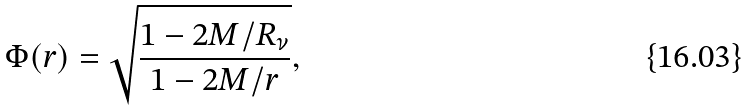Convert formula to latex. <formula><loc_0><loc_0><loc_500><loc_500>\Phi ( r ) = \sqrt { \frac { 1 - 2 M / R _ { \nu } } { 1 - 2 M / r } } ,</formula> 